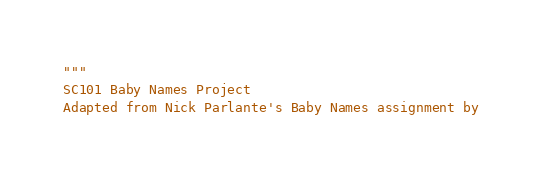<code> <loc_0><loc_0><loc_500><loc_500><_Python_>"""
SC101 Baby Names Project
Adapted from Nick Parlante's Baby Names assignment by</code> 